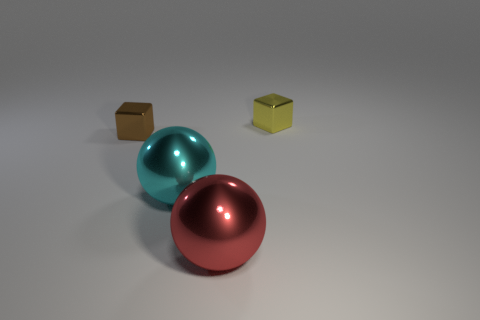Add 2 yellow metal cylinders. How many objects exist? 6 Add 4 small metallic blocks. How many small metallic blocks are left? 6 Add 2 cyan shiny balls. How many cyan shiny balls exist? 3 Subtract 0 blue blocks. How many objects are left? 4 Subtract all tiny cyan shiny things. Subtract all large shiny objects. How many objects are left? 2 